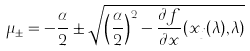<formula> <loc_0><loc_0><loc_500><loc_500>\mu _ { \pm } = - \frac { \alpha } { 2 } \pm \sqrt { \left ( \frac { \alpha } { 2 } \right ) ^ { 2 } - \frac { \partial f } { \partial x } ( x _ { j } ( \lambda ) , \lambda ) }</formula> 